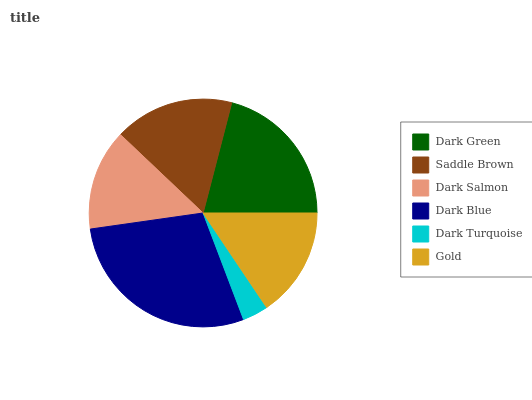Is Dark Turquoise the minimum?
Answer yes or no. Yes. Is Dark Blue the maximum?
Answer yes or no. Yes. Is Saddle Brown the minimum?
Answer yes or no. No. Is Saddle Brown the maximum?
Answer yes or no. No. Is Dark Green greater than Saddle Brown?
Answer yes or no. Yes. Is Saddle Brown less than Dark Green?
Answer yes or no. Yes. Is Saddle Brown greater than Dark Green?
Answer yes or no. No. Is Dark Green less than Saddle Brown?
Answer yes or no. No. Is Saddle Brown the high median?
Answer yes or no. Yes. Is Gold the low median?
Answer yes or no. Yes. Is Dark Turquoise the high median?
Answer yes or no. No. Is Dark Green the low median?
Answer yes or no. No. 